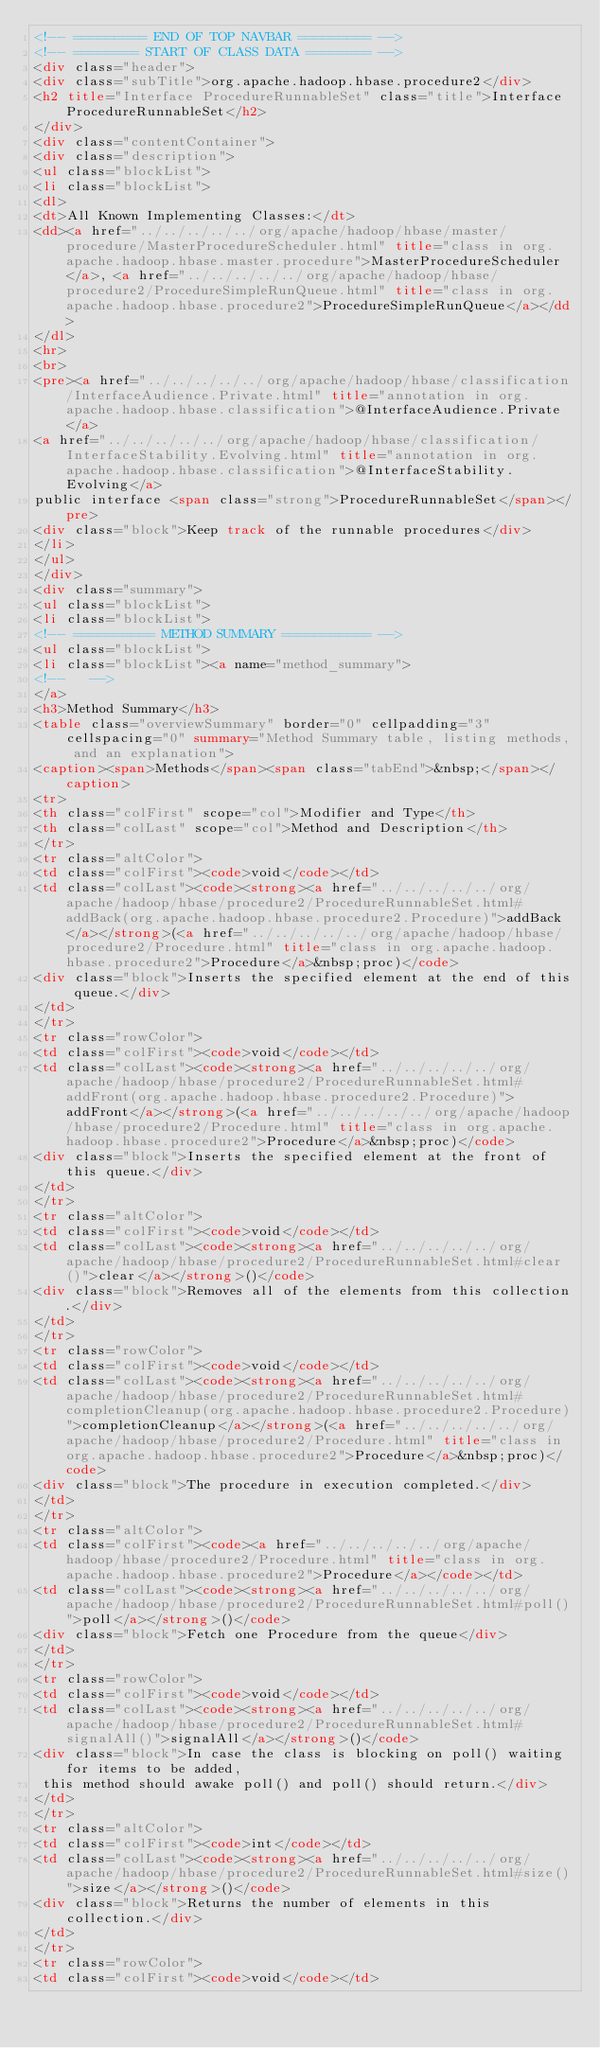<code> <loc_0><loc_0><loc_500><loc_500><_HTML_><!-- ========= END OF TOP NAVBAR ========= -->
<!-- ======== START OF CLASS DATA ======== -->
<div class="header">
<div class="subTitle">org.apache.hadoop.hbase.procedure2</div>
<h2 title="Interface ProcedureRunnableSet" class="title">Interface ProcedureRunnableSet</h2>
</div>
<div class="contentContainer">
<div class="description">
<ul class="blockList">
<li class="blockList">
<dl>
<dt>All Known Implementing Classes:</dt>
<dd><a href="../../../../../org/apache/hadoop/hbase/master/procedure/MasterProcedureScheduler.html" title="class in org.apache.hadoop.hbase.master.procedure">MasterProcedureScheduler</a>, <a href="../../../../../org/apache/hadoop/hbase/procedure2/ProcedureSimpleRunQueue.html" title="class in org.apache.hadoop.hbase.procedure2">ProcedureSimpleRunQueue</a></dd>
</dl>
<hr>
<br>
<pre><a href="../../../../../org/apache/hadoop/hbase/classification/InterfaceAudience.Private.html" title="annotation in org.apache.hadoop.hbase.classification">@InterfaceAudience.Private</a>
<a href="../../../../../org/apache/hadoop/hbase/classification/InterfaceStability.Evolving.html" title="annotation in org.apache.hadoop.hbase.classification">@InterfaceStability.Evolving</a>
public interface <span class="strong">ProcedureRunnableSet</span></pre>
<div class="block">Keep track of the runnable procedures</div>
</li>
</ul>
</div>
<div class="summary">
<ul class="blockList">
<li class="blockList">
<!-- ========== METHOD SUMMARY =========== -->
<ul class="blockList">
<li class="blockList"><a name="method_summary">
<!--   -->
</a>
<h3>Method Summary</h3>
<table class="overviewSummary" border="0" cellpadding="3" cellspacing="0" summary="Method Summary table, listing methods, and an explanation">
<caption><span>Methods</span><span class="tabEnd">&nbsp;</span></caption>
<tr>
<th class="colFirst" scope="col">Modifier and Type</th>
<th class="colLast" scope="col">Method and Description</th>
</tr>
<tr class="altColor">
<td class="colFirst"><code>void</code></td>
<td class="colLast"><code><strong><a href="../../../../../org/apache/hadoop/hbase/procedure2/ProcedureRunnableSet.html#addBack(org.apache.hadoop.hbase.procedure2.Procedure)">addBack</a></strong>(<a href="../../../../../org/apache/hadoop/hbase/procedure2/Procedure.html" title="class in org.apache.hadoop.hbase.procedure2">Procedure</a>&nbsp;proc)</code>
<div class="block">Inserts the specified element at the end of this queue.</div>
</td>
</tr>
<tr class="rowColor">
<td class="colFirst"><code>void</code></td>
<td class="colLast"><code><strong><a href="../../../../../org/apache/hadoop/hbase/procedure2/ProcedureRunnableSet.html#addFront(org.apache.hadoop.hbase.procedure2.Procedure)">addFront</a></strong>(<a href="../../../../../org/apache/hadoop/hbase/procedure2/Procedure.html" title="class in org.apache.hadoop.hbase.procedure2">Procedure</a>&nbsp;proc)</code>
<div class="block">Inserts the specified element at the front of this queue.</div>
</td>
</tr>
<tr class="altColor">
<td class="colFirst"><code>void</code></td>
<td class="colLast"><code><strong><a href="../../../../../org/apache/hadoop/hbase/procedure2/ProcedureRunnableSet.html#clear()">clear</a></strong>()</code>
<div class="block">Removes all of the elements from this collection.</div>
</td>
</tr>
<tr class="rowColor">
<td class="colFirst"><code>void</code></td>
<td class="colLast"><code><strong><a href="../../../../../org/apache/hadoop/hbase/procedure2/ProcedureRunnableSet.html#completionCleanup(org.apache.hadoop.hbase.procedure2.Procedure)">completionCleanup</a></strong>(<a href="../../../../../org/apache/hadoop/hbase/procedure2/Procedure.html" title="class in org.apache.hadoop.hbase.procedure2">Procedure</a>&nbsp;proc)</code>
<div class="block">The procedure in execution completed.</div>
</td>
</tr>
<tr class="altColor">
<td class="colFirst"><code><a href="../../../../../org/apache/hadoop/hbase/procedure2/Procedure.html" title="class in org.apache.hadoop.hbase.procedure2">Procedure</a></code></td>
<td class="colLast"><code><strong><a href="../../../../../org/apache/hadoop/hbase/procedure2/ProcedureRunnableSet.html#poll()">poll</a></strong>()</code>
<div class="block">Fetch one Procedure from the queue</div>
</td>
</tr>
<tr class="rowColor">
<td class="colFirst"><code>void</code></td>
<td class="colLast"><code><strong><a href="../../../../../org/apache/hadoop/hbase/procedure2/ProcedureRunnableSet.html#signalAll()">signalAll</a></strong>()</code>
<div class="block">In case the class is blocking on poll() waiting for items to be added,
 this method should awake poll() and poll() should return.</div>
</td>
</tr>
<tr class="altColor">
<td class="colFirst"><code>int</code></td>
<td class="colLast"><code><strong><a href="../../../../../org/apache/hadoop/hbase/procedure2/ProcedureRunnableSet.html#size()">size</a></strong>()</code>
<div class="block">Returns the number of elements in this collection.</div>
</td>
</tr>
<tr class="rowColor">
<td class="colFirst"><code>void</code></td></code> 